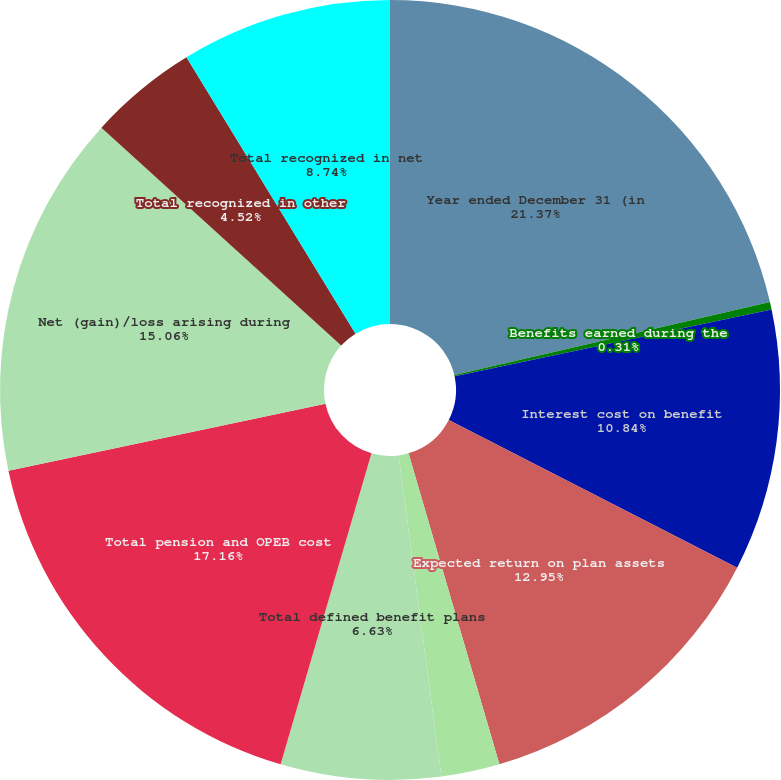<chart> <loc_0><loc_0><loc_500><loc_500><pie_chart><fcel>Year ended December 31 (in<fcel>Benefits earned during the<fcel>Interest cost on benefit<fcel>Expected return on plan assets<fcel>Net periodic benefit cost<fcel>Total defined benefit plans<fcel>Total pension and OPEB cost<fcel>Net (gain)/loss arising during<fcel>Total recognized in other<fcel>Total recognized in net<nl><fcel>21.38%<fcel>0.31%<fcel>10.84%<fcel>12.95%<fcel>2.42%<fcel>6.63%<fcel>17.16%<fcel>15.06%<fcel>4.52%<fcel>8.74%<nl></chart> 